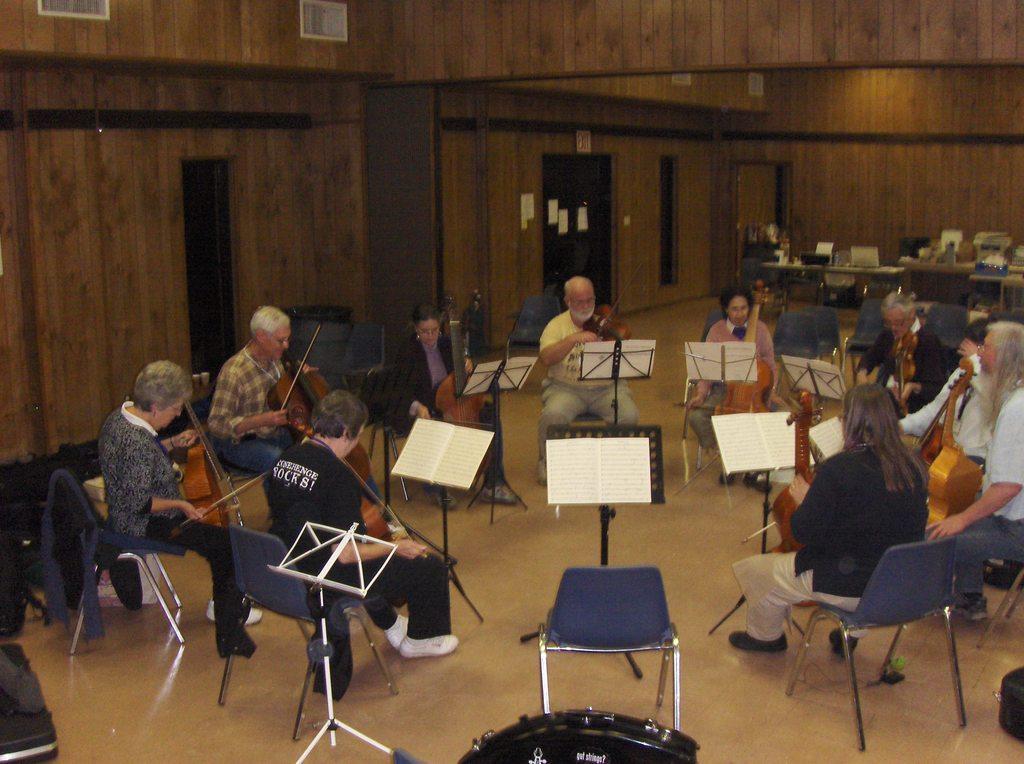How would you summarize this image in a sentence or two? In this picture, there is a floor which is in yellow color, there are some people sitting on the chairs which are in blue color, there are some stands which are in black color, there are some paper which of the stands which are in white color, in the background there is a wall which is in brown color, there are some doors which are in black color. 